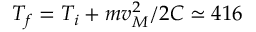Convert formula to latex. <formula><loc_0><loc_0><loc_500><loc_500>T _ { f } = T _ { i } + m v _ { M } ^ { 2 } / 2 C \simeq 4 1 6</formula> 